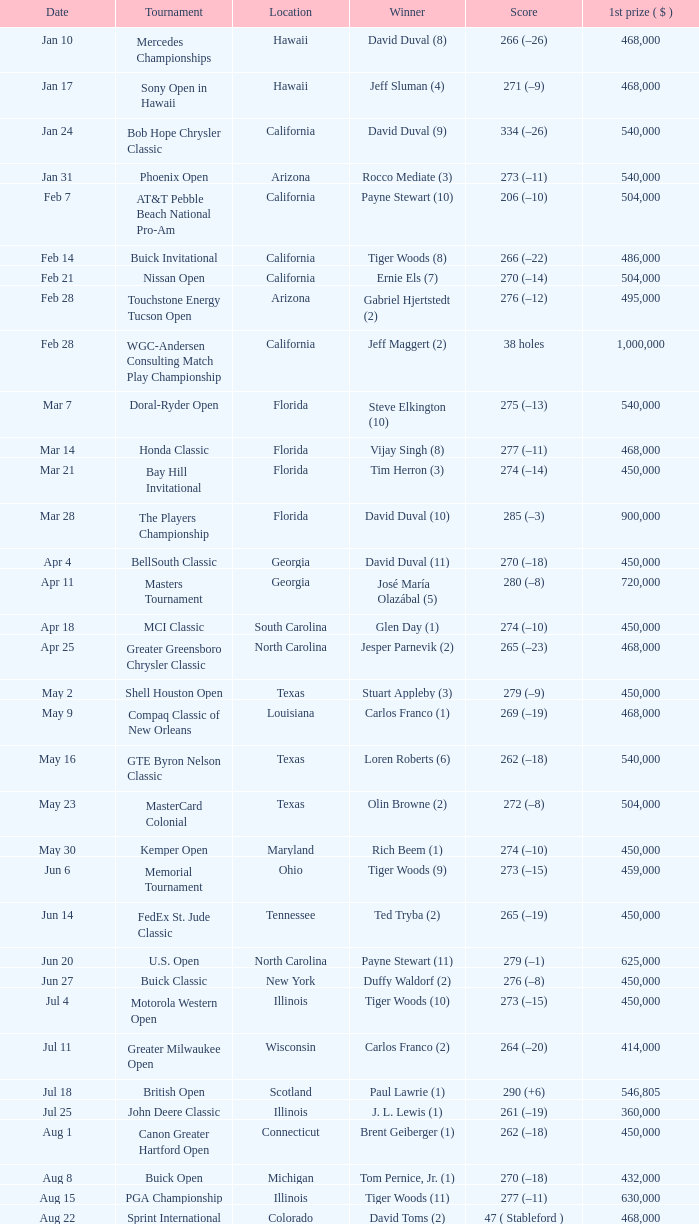What is the date of the Greater Greensboro Chrysler Classic? Apr 25. 